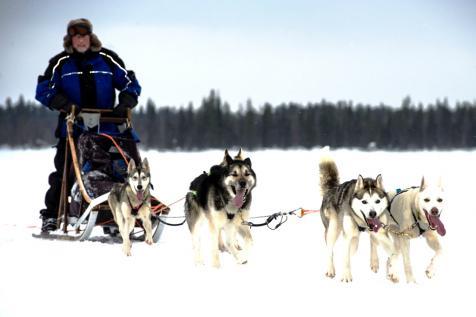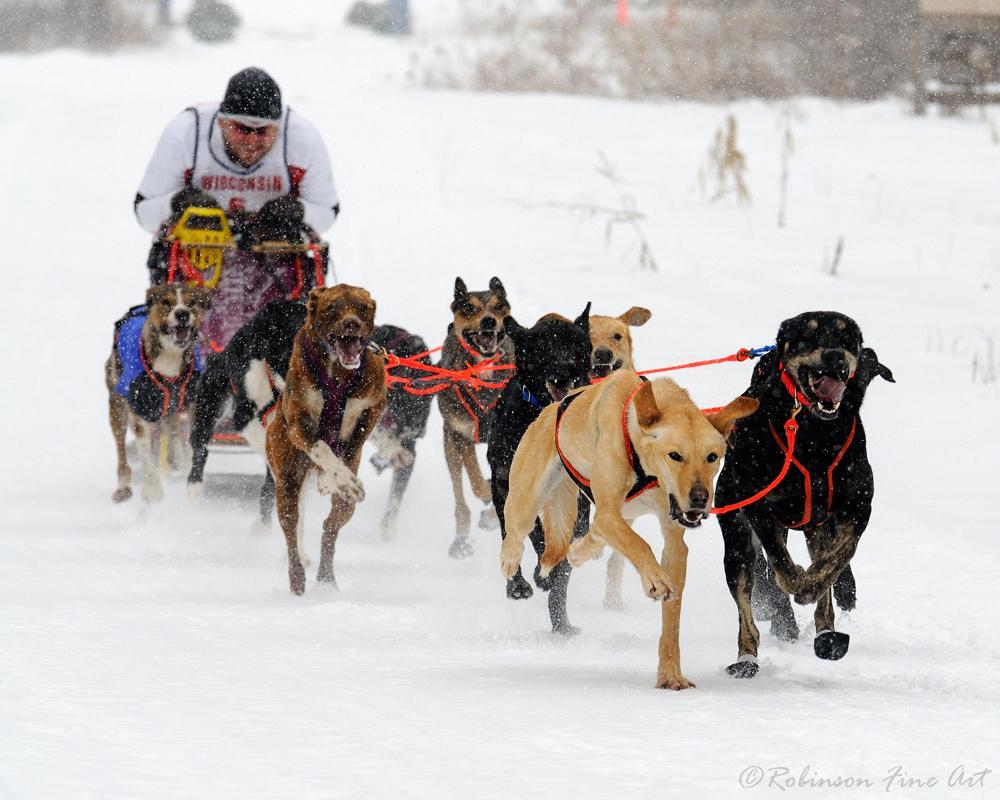The first image is the image on the left, the second image is the image on the right. Analyze the images presented: Is the assertion "The dog teams in the two images are each forward-facing, but headed in different directions." valid? Answer yes or no. No. 